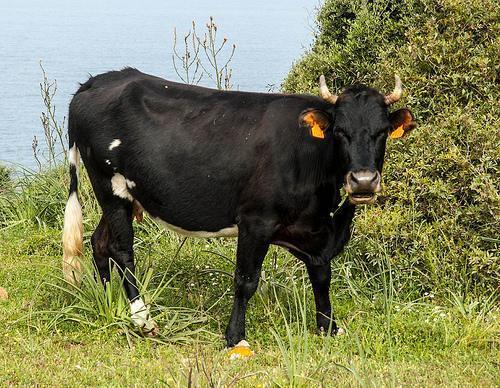How many horns does the bull have?
Give a very brief answer. 2. 